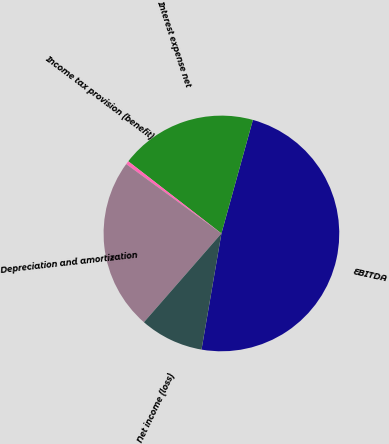<chart> <loc_0><loc_0><loc_500><loc_500><pie_chart><fcel>EBITDA<fcel>Interest expense net<fcel>Income tax provision (benefit)<fcel>Depreciation and amortization<fcel>Net income (loss)<nl><fcel>48.4%<fcel>18.81%<fcel>0.47%<fcel>23.6%<fcel>8.72%<nl></chart> 